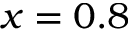<formula> <loc_0><loc_0><loc_500><loc_500>x = 0 . 8</formula> 